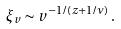<formula> <loc_0><loc_0><loc_500><loc_500>\xi _ { v } \sim v ^ { - 1 / ( z + 1 / \nu ) } \, .</formula> 